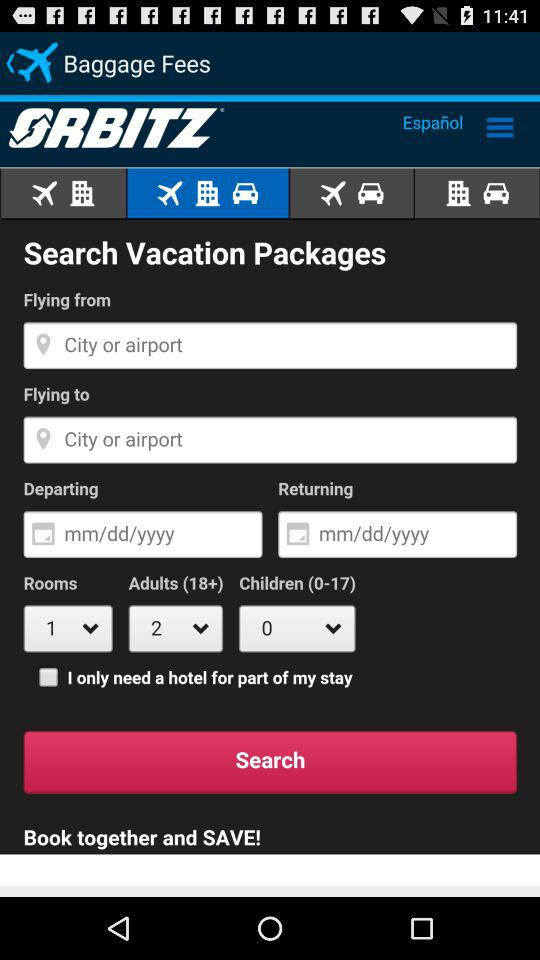How many more adults are there than children?
Answer the question using a single word or phrase. 2 